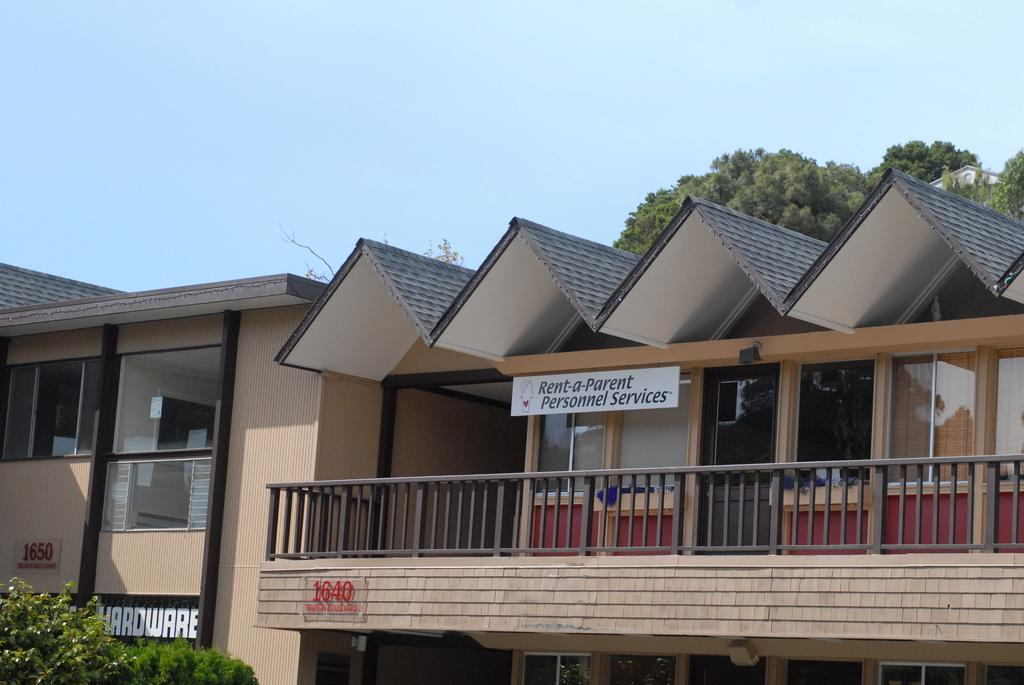What type of structures can be seen in the image? There are houses in the image. What type of vegetation is present in the image? There are trees in the image. What is visible at the top of the image? The sky is visible at the top of the image and appears to be clear. Can you see any rocks in the image? There are no rocks visible in the image. Are there any shoes present in the image? There are no shoes present in the image. 